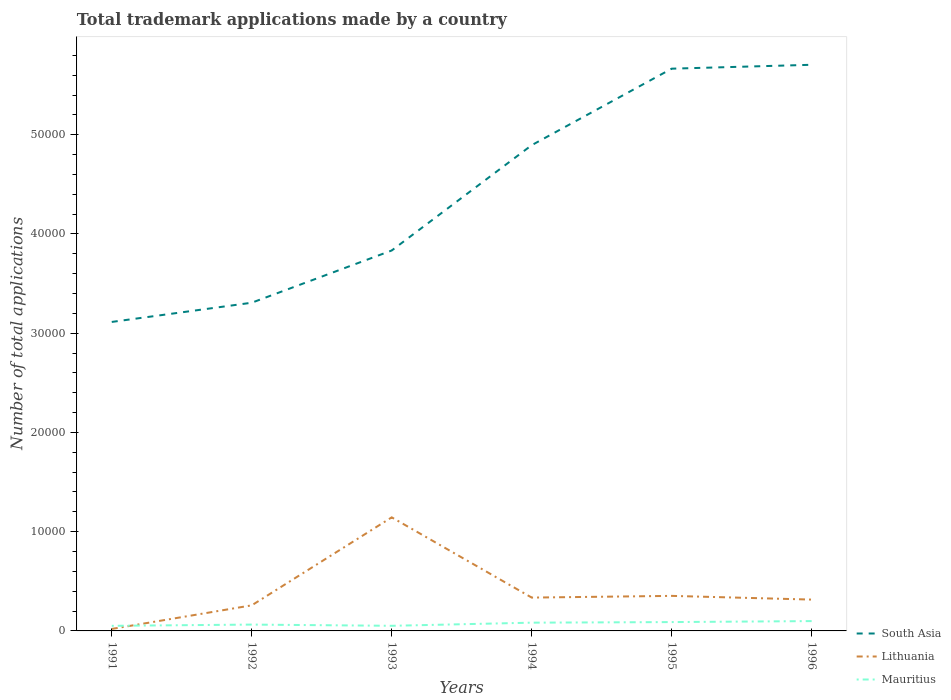How many different coloured lines are there?
Provide a succinct answer. 3. Does the line corresponding to Lithuania intersect with the line corresponding to South Asia?
Give a very brief answer. No. Across all years, what is the maximum number of applications made by in South Asia?
Ensure brevity in your answer.  3.11e+04. In which year was the number of applications made by in Mauritius maximum?
Your answer should be very brief. 1991. What is the total number of applications made by in Lithuania in the graph?
Your answer should be compact. -579. What is the difference between the highest and the second highest number of applications made by in South Asia?
Provide a short and direct response. 2.59e+04. How many years are there in the graph?
Offer a terse response. 6. What is the difference between two consecutive major ticks on the Y-axis?
Your response must be concise. 10000. Are the values on the major ticks of Y-axis written in scientific E-notation?
Your answer should be very brief. No. Does the graph contain grids?
Offer a very short reply. No. How are the legend labels stacked?
Make the answer very short. Vertical. What is the title of the graph?
Offer a very short reply. Total trademark applications made by a country. What is the label or title of the Y-axis?
Offer a terse response. Number of total applications. What is the Number of total applications of South Asia in 1991?
Offer a very short reply. 3.11e+04. What is the Number of total applications of Lithuania in 1991?
Make the answer very short. 200. What is the Number of total applications in Mauritius in 1991?
Keep it short and to the point. 513. What is the Number of total applications in South Asia in 1992?
Provide a short and direct response. 3.31e+04. What is the Number of total applications of Lithuania in 1992?
Offer a very short reply. 2578. What is the Number of total applications of Mauritius in 1992?
Give a very brief answer. 639. What is the Number of total applications in South Asia in 1993?
Provide a succinct answer. 3.83e+04. What is the Number of total applications in Lithuania in 1993?
Your answer should be very brief. 1.14e+04. What is the Number of total applications in Mauritius in 1993?
Keep it short and to the point. 516. What is the Number of total applications of South Asia in 1994?
Provide a short and direct response. 4.90e+04. What is the Number of total applications of Lithuania in 1994?
Keep it short and to the point. 3359. What is the Number of total applications of Mauritius in 1994?
Offer a terse response. 832. What is the Number of total applications in South Asia in 1995?
Your answer should be compact. 5.67e+04. What is the Number of total applications of Lithuania in 1995?
Ensure brevity in your answer.  3531. What is the Number of total applications in Mauritius in 1995?
Keep it short and to the point. 891. What is the Number of total applications of South Asia in 1996?
Offer a terse response. 5.71e+04. What is the Number of total applications of Lithuania in 1996?
Ensure brevity in your answer.  3157. What is the Number of total applications in Mauritius in 1996?
Make the answer very short. 991. Across all years, what is the maximum Number of total applications in South Asia?
Your answer should be very brief. 5.71e+04. Across all years, what is the maximum Number of total applications in Lithuania?
Your answer should be very brief. 1.14e+04. Across all years, what is the maximum Number of total applications in Mauritius?
Your answer should be compact. 991. Across all years, what is the minimum Number of total applications of South Asia?
Provide a short and direct response. 3.11e+04. Across all years, what is the minimum Number of total applications of Mauritius?
Your answer should be compact. 513. What is the total Number of total applications in South Asia in the graph?
Your answer should be very brief. 2.65e+05. What is the total Number of total applications of Lithuania in the graph?
Offer a very short reply. 2.43e+04. What is the total Number of total applications in Mauritius in the graph?
Your answer should be very brief. 4382. What is the difference between the Number of total applications of South Asia in 1991 and that in 1992?
Give a very brief answer. -1937. What is the difference between the Number of total applications of Lithuania in 1991 and that in 1992?
Offer a very short reply. -2378. What is the difference between the Number of total applications of Mauritius in 1991 and that in 1992?
Provide a short and direct response. -126. What is the difference between the Number of total applications of South Asia in 1991 and that in 1993?
Your response must be concise. -7200. What is the difference between the Number of total applications in Lithuania in 1991 and that in 1993?
Keep it short and to the point. -1.12e+04. What is the difference between the Number of total applications in Mauritius in 1991 and that in 1993?
Give a very brief answer. -3. What is the difference between the Number of total applications in South Asia in 1991 and that in 1994?
Ensure brevity in your answer.  -1.78e+04. What is the difference between the Number of total applications in Lithuania in 1991 and that in 1994?
Make the answer very short. -3159. What is the difference between the Number of total applications in Mauritius in 1991 and that in 1994?
Ensure brevity in your answer.  -319. What is the difference between the Number of total applications of South Asia in 1991 and that in 1995?
Keep it short and to the point. -2.55e+04. What is the difference between the Number of total applications of Lithuania in 1991 and that in 1995?
Keep it short and to the point. -3331. What is the difference between the Number of total applications of Mauritius in 1991 and that in 1995?
Offer a very short reply. -378. What is the difference between the Number of total applications of South Asia in 1991 and that in 1996?
Offer a terse response. -2.59e+04. What is the difference between the Number of total applications in Lithuania in 1991 and that in 1996?
Offer a terse response. -2957. What is the difference between the Number of total applications in Mauritius in 1991 and that in 1996?
Make the answer very short. -478. What is the difference between the Number of total applications of South Asia in 1992 and that in 1993?
Make the answer very short. -5263. What is the difference between the Number of total applications in Lithuania in 1992 and that in 1993?
Offer a terse response. -8867. What is the difference between the Number of total applications in Mauritius in 1992 and that in 1993?
Your response must be concise. 123. What is the difference between the Number of total applications in South Asia in 1992 and that in 1994?
Offer a very short reply. -1.59e+04. What is the difference between the Number of total applications in Lithuania in 1992 and that in 1994?
Your answer should be very brief. -781. What is the difference between the Number of total applications of Mauritius in 1992 and that in 1994?
Give a very brief answer. -193. What is the difference between the Number of total applications of South Asia in 1992 and that in 1995?
Your response must be concise. -2.36e+04. What is the difference between the Number of total applications of Lithuania in 1992 and that in 1995?
Offer a very short reply. -953. What is the difference between the Number of total applications in Mauritius in 1992 and that in 1995?
Your answer should be very brief. -252. What is the difference between the Number of total applications of South Asia in 1992 and that in 1996?
Provide a short and direct response. -2.40e+04. What is the difference between the Number of total applications of Lithuania in 1992 and that in 1996?
Give a very brief answer. -579. What is the difference between the Number of total applications of Mauritius in 1992 and that in 1996?
Keep it short and to the point. -352. What is the difference between the Number of total applications of South Asia in 1993 and that in 1994?
Your answer should be very brief. -1.06e+04. What is the difference between the Number of total applications of Lithuania in 1993 and that in 1994?
Your response must be concise. 8086. What is the difference between the Number of total applications in Mauritius in 1993 and that in 1994?
Your response must be concise. -316. What is the difference between the Number of total applications of South Asia in 1993 and that in 1995?
Provide a succinct answer. -1.83e+04. What is the difference between the Number of total applications of Lithuania in 1993 and that in 1995?
Make the answer very short. 7914. What is the difference between the Number of total applications in Mauritius in 1993 and that in 1995?
Your answer should be very brief. -375. What is the difference between the Number of total applications in South Asia in 1993 and that in 1996?
Offer a terse response. -1.87e+04. What is the difference between the Number of total applications of Lithuania in 1993 and that in 1996?
Give a very brief answer. 8288. What is the difference between the Number of total applications in Mauritius in 1993 and that in 1996?
Keep it short and to the point. -475. What is the difference between the Number of total applications in South Asia in 1994 and that in 1995?
Give a very brief answer. -7709. What is the difference between the Number of total applications in Lithuania in 1994 and that in 1995?
Make the answer very short. -172. What is the difference between the Number of total applications of Mauritius in 1994 and that in 1995?
Your response must be concise. -59. What is the difference between the Number of total applications of South Asia in 1994 and that in 1996?
Ensure brevity in your answer.  -8101. What is the difference between the Number of total applications of Lithuania in 1994 and that in 1996?
Provide a succinct answer. 202. What is the difference between the Number of total applications in Mauritius in 1994 and that in 1996?
Provide a succinct answer. -159. What is the difference between the Number of total applications of South Asia in 1995 and that in 1996?
Offer a terse response. -392. What is the difference between the Number of total applications of Lithuania in 1995 and that in 1996?
Keep it short and to the point. 374. What is the difference between the Number of total applications in Mauritius in 1995 and that in 1996?
Your answer should be compact. -100. What is the difference between the Number of total applications in South Asia in 1991 and the Number of total applications in Lithuania in 1992?
Ensure brevity in your answer.  2.86e+04. What is the difference between the Number of total applications of South Asia in 1991 and the Number of total applications of Mauritius in 1992?
Provide a succinct answer. 3.05e+04. What is the difference between the Number of total applications of Lithuania in 1991 and the Number of total applications of Mauritius in 1992?
Ensure brevity in your answer.  -439. What is the difference between the Number of total applications of South Asia in 1991 and the Number of total applications of Lithuania in 1993?
Give a very brief answer. 1.97e+04. What is the difference between the Number of total applications of South Asia in 1991 and the Number of total applications of Mauritius in 1993?
Give a very brief answer. 3.06e+04. What is the difference between the Number of total applications in Lithuania in 1991 and the Number of total applications in Mauritius in 1993?
Provide a short and direct response. -316. What is the difference between the Number of total applications of South Asia in 1991 and the Number of total applications of Lithuania in 1994?
Keep it short and to the point. 2.78e+04. What is the difference between the Number of total applications in South Asia in 1991 and the Number of total applications in Mauritius in 1994?
Give a very brief answer. 3.03e+04. What is the difference between the Number of total applications of Lithuania in 1991 and the Number of total applications of Mauritius in 1994?
Give a very brief answer. -632. What is the difference between the Number of total applications in South Asia in 1991 and the Number of total applications in Lithuania in 1995?
Your response must be concise. 2.76e+04. What is the difference between the Number of total applications of South Asia in 1991 and the Number of total applications of Mauritius in 1995?
Your answer should be very brief. 3.02e+04. What is the difference between the Number of total applications in Lithuania in 1991 and the Number of total applications in Mauritius in 1995?
Provide a succinct answer. -691. What is the difference between the Number of total applications of South Asia in 1991 and the Number of total applications of Lithuania in 1996?
Give a very brief answer. 2.80e+04. What is the difference between the Number of total applications of South Asia in 1991 and the Number of total applications of Mauritius in 1996?
Provide a succinct answer. 3.01e+04. What is the difference between the Number of total applications in Lithuania in 1991 and the Number of total applications in Mauritius in 1996?
Keep it short and to the point. -791. What is the difference between the Number of total applications of South Asia in 1992 and the Number of total applications of Lithuania in 1993?
Ensure brevity in your answer.  2.16e+04. What is the difference between the Number of total applications in South Asia in 1992 and the Number of total applications in Mauritius in 1993?
Give a very brief answer. 3.26e+04. What is the difference between the Number of total applications in Lithuania in 1992 and the Number of total applications in Mauritius in 1993?
Your response must be concise. 2062. What is the difference between the Number of total applications in South Asia in 1992 and the Number of total applications in Lithuania in 1994?
Offer a very short reply. 2.97e+04. What is the difference between the Number of total applications in South Asia in 1992 and the Number of total applications in Mauritius in 1994?
Keep it short and to the point. 3.22e+04. What is the difference between the Number of total applications in Lithuania in 1992 and the Number of total applications in Mauritius in 1994?
Offer a very short reply. 1746. What is the difference between the Number of total applications in South Asia in 1992 and the Number of total applications in Lithuania in 1995?
Provide a succinct answer. 2.95e+04. What is the difference between the Number of total applications in South Asia in 1992 and the Number of total applications in Mauritius in 1995?
Your answer should be compact. 3.22e+04. What is the difference between the Number of total applications of Lithuania in 1992 and the Number of total applications of Mauritius in 1995?
Give a very brief answer. 1687. What is the difference between the Number of total applications of South Asia in 1992 and the Number of total applications of Lithuania in 1996?
Keep it short and to the point. 2.99e+04. What is the difference between the Number of total applications of South Asia in 1992 and the Number of total applications of Mauritius in 1996?
Make the answer very short. 3.21e+04. What is the difference between the Number of total applications of Lithuania in 1992 and the Number of total applications of Mauritius in 1996?
Your answer should be very brief. 1587. What is the difference between the Number of total applications of South Asia in 1993 and the Number of total applications of Lithuania in 1994?
Provide a short and direct response. 3.50e+04. What is the difference between the Number of total applications in South Asia in 1993 and the Number of total applications in Mauritius in 1994?
Your response must be concise. 3.75e+04. What is the difference between the Number of total applications in Lithuania in 1993 and the Number of total applications in Mauritius in 1994?
Your response must be concise. 1.06e+04. What is the difference between the Number of total applications of South Asia in 1993 and the Number of total applications of Lithuania in 1995?
Give a very brief answer. 3.48e+04. What is the difference between the Number of total applications of South Asia in 1993 and the Number of total applications of Mauritius in 1995?
Your answer should be compact. 3.74e+04. What is the difference between the Number of total applications in Lithuania in 1993 and the Number of total applications in Mauritius in 1995?
Offer a very short reply. 1.06e+04. What is the difference between the Number of total applications of South Asia in 1993 and the Number of total applications of Lithuania in 1996?
Your answer should be compact. 3.52e+04. What is the difference between the Number of total applications in South Asia in 1993 and the Number of total applications in Mauritius in 1996?
Give a very brief answer. 3.73e+04. What is the difference between the Number of total applications in Lithuania in 1993 and the Number of total applications in Mauritius in 1996?
Keep it short and to the point. 1.05e+04. What is the difference between the Number of total applications in South Asia in 1994 and the Number of total applications in Lithuania in 1995?
Give a very brief answer. 4.54e+04. What is the difference between the Number of total applications of South Asia in 1994 and the Number of total applications of Mauritius in 1995?
Give a very brief answer. 4.81e+04. What is the difference between the Number of total applications in Lithuania in 1994 and the Number of total applications in Mauritius in 1995?
Your response must be concise. 2468. What is the difference between the Number of total applications in South Asia in 1994 and the Number of total applications in Lithuania in 1996?
Your answer should be compact. 4.58e+04. What is the difference between the Number of total applications in South Asia in 1994 and the Number of total applications in Mauritius in 1996?
Make the answer very short. 4.80e+04. What is the difference between the Number of total applications of Lithuania in 1994 and the Number of total applications of Mauritius in 1996?
Your answer should be very brief. 2368. What is the difference between the Number of total applications in South Asia in 1995 and the Number of total applications in Lithuania in 1996?
Ensure brevity in your answer.  5.35e+04. What is the difference between the Number of total applications in South Asia in 1995 and the Number of total applications in Mauritius in 1996?
Keep it short and to the point. 5.57e+04. What is the difference between the Number of total applications of Lithuania in 1995 and the Number of total applications of Mauritius in 1996?
Your response must be concise. 2540. What is the average Number of total applications in South Asia per year?
Offer a very short reply. 4.42e+04. What is the average Number of total applications in Lithuania per year?
Your response must be concise. 4045. What is the average Number of total applications in Mauritius per year?
Make the answer very short. 730.33. In the year 1991, what is the difference between the Number of total applications in South Asia and Number of total applications in Lithuania?
Your response must be concise. 3.09e+04. In the year 1991, what is the difference between the Number of total applications of South Asia and Number of total applications of Mauritius?
Ensure brevity in your answer.  3.06e+04. In the year 1991, what is the difference between the Number of total applications in Lithuania and Number of total applications in Mauritius?
Give a very brief answer. -313. In the year 1992, what is the difference between the Number of total applications of South Asia and Number of total applications of Lithuania?
Give a very brief answer. 3.05e+04. In the year 1992, what is the difference between the Number of total applications in South Asia and Number of total applications in Mauritius?
Offer a terse response. 3.24e+04. In the year 1992, what is the difference between the Number of total applications of Lithuania and Number of total applications of Mauritius?
Your answer should be compact. 1939. In the year 1993, what is the difference between the Number of total applications in South Asia and Number of total applications in Lithuania?
Your answer should be very brief. 2.69e+04. In the year 1993, what is the difference between the Number of total applications of South Asia and Number of total applications of Mauritius?
Provide a succinct answer. 3.78e+04. In the year 1993, what is the difference between the Number of total applications in Lithuania and Number of total applications in Mauritius?
Offer a very short reply. 1.09e+04. In the year 1994, what is the difference between the Number of total applications of South Asia and Number of total applications of Lithuania?
Provide a succinct answer. 4.56e+04. In the year 1994, what is the difference between the Number of total applications of South Asia and Number of total applications of Mauritius?
Provide a succinct answer. 4.81e+04. In the year 1994, what is the difference between the Number of total applications in Lithuania and Number of total applications in Mauritius?
Provide a short and direct response. 2527. In the year 1995, what is the difference between the Number of total applications of South Asia and Number of total applications of Lithuania?
Your answer should be compact. 5.31e+04. In the year 1995, what is the difference between the Number of total applications in South Asia and Number of total applications in Mauritius?
Give a very brief answer. 5.58e+04. In the year 1995, what is the difference between the Number of total applications of Lithuania and Number of total applications of Mauritius?
Your response must be concise. 2640. In the year 1996, what is the difference between the Number of total applications of South Asia and Number of total applications of Lithuania?
Your answer should be compact. 5.39e+04. In the year 1996, what is the difference between the Number of total applications in South Asia and Number of total applications in Mauritius?
Make the answer very short. 5.61e+04. In the year 1996, what is the difference between the Number of total applications in Lithuania and Number of total applications in Mauritius?
Make the answer very short. 2166. What is the ratio of the Number of total applications in South Asia in 1991 to that in 1992?
Make the answer very short. 0.94. What is the ratio of the Number of total applications in Lithuania in 1991 to that in 1992?
Offer a terse response. 0.08. What is the ratio of the Number of total applications in Mauritius in 1991 to that in 1992?
Give a very brief answer. 0.8. What is the ratio of the Number of total applications in South Asia in 1991 to that in 1993?
Offer a very short reply. 0.81. What is the ratio of the Number of total applications of Lithuania in 1991 to that in 1993?
Provide a short and direct response. 0.02. What is the ratio of the Number of total applications of Mauritius in 1991 to that in 1993?
Offer a very short reply. 0.99. What is the ratio of the Number of total applications of South Asia in 1991 to that in 1994?
Make the answer very short. 0.64. What is the ratio of the Number of total applications in Lithuania in 1991 to that in 1994?
Give a very brief answer. 0.06. What is the ratio of the Number of total applications in Mauritius in 1991 to that in 1994?
Give a very brief answer. 0.62. What is the ratio of the Number of total applications in South Asia in 1991 to that in 1995?
Give a very brief answer. 0.55. What is the ratio of the Number of total applications in Lithuania in 1991 to that in 1995?
Ensure brevity in your answer.  0.06. What is the ratio of the Number of total applications in Mauritius in 1991 to that in 1995?
Offer a terse response. 0.58. What is the ratio of the Number of total applications in South Asia in 1991 to that in 1996?
Your answer should be compact. 0.55. What is the ratio of the Number of total applications of Lithuania in 1991 to that in 1996?
Your response must be concise. 0.06. What is the ratio of the Number of total applications of Mauritius in 1991 to that in 1996?
Provide a short and direct response. 0.52. What is the ratio of the Number of total applications of South Asia in 1992 to that in 1993?
Provide a succinct answer. 0.86. What is the ratio of the Number of total applications of Lithuania in 1992 to that in 1993?
Give a very brief answer. 0.23. What is the ratio of the Number of total applications of Mauritius in 1992 to that in 1993?
Keep it short and to the point. 1.24. What is the ratio of the Number of total applications of South Asia in 1992 to that in 1994?
Provide a short and direct response. 0.68. What is the ratio of the Number of total applications of Lithuania in 1992 to that in 1994?
Offer a very short reply. 0.77. What is the ratio of the Number of total applications in Mauritius in 1992 to that in 1994?
Make the answer very short. 0.77. What is the ratio of the Number of total applications in South Asia in 1992 to that in 1995?
Your response must be concise. 0.58. What is the ratio of the Number of total applications of Lithuania in 1992 to that in 1995?
Offer a very short reply. 0.73. What is the ratio of the Number of total applications of Mauritius in 1992 to that in 1995?
Your answer should be compact. 0.72. What is the ratio of the Number of total applications of South Asia in 1992 to that in 1996?
Give a very brief answer. 0.58. What is the ratio of the Number of total applications of Lithuania in 1992 to that in 1996?
Your answer should be compact. 0.82. What is the ratio of the Number of total applications of Mauritius in 1992 to that in 1996?
Keep it short and to the point. 0.64. What is the ratio of the Number of total applications in South Asia in 1993 to that in 1994?
Provide a succinct answer. 0.78. What is the ratio of the Number of total applications of Lithuania in 1993 to that in 1994?
Ensure brevity in your answer.  3.41. What is the ratio of the Number of total applications in Mauritius in 1993 to that in 1994?
Provide a succinct answer. 0.62. What is the ratio of the Number of total applications of South Asia in 1993 to that in 1995?
Your answer should be compact. 0.68. What is the ratio of the Number of total applications in Lithuania in 1993 to that in 1995?
Provide a succinct answer. 3.24. What is the ratio of the Number of total applications in Mauritius in 1993 to that in 1995?
Give a very brief answer. 0.58. What is the ratio of the Number of total applications of South Asia in 1993 to that in 1996?
Offer a very short reply. 0.67. What is the ratio of the Number of total applications in Lithuania in 1993 to that in 1996?
Ensure brevity in your answer.  3.63. What is the ratio of the Number of total applications in Mauritius in 1993 to that in 1996?
Your answer should be very brief. 0.52. What is the ratio of the Number of total applications in South Asia in 1994 to that in 1995?
Offer a terse response. 0.86. What is the ratio of the Number of total applications in Lithuania in 1994 to that in 1995?
Keep it short and to the point. 0.95. What is the ratio of the Number of total applications of Mauritius in 1994 to that in 1995?
Your response must be concise. 0.93. What is the ratio of the Number of total applications in South Asia in 1994 to that in 1996?
Give a very brief answer. 0.86. What is the ratio of the Number of total applications of Lithuania in 1994 to that in 1996?
Make the answer very short. 1.06. What is the ratio of the Number of total applications of Mauritius in 1994 to that in 1996?
Your answer should be very brief. 0.84. What is the ratio of the Number of total applications in South Asia in 1995 to that in 1996?
Keep it short and to the point. 0.99. What is the ratio of the Number of total applications in Lithuania in 1995 to that in 1996?
Your response must be concise. 1.12. What is the ratio of the Number of total applications of Mauritius in 1995 to that in 1996?
Give a very brief answer. 0.9. What is the difference between the highest and the second highest Number of total applications of South Asia?
Provide a short and direct response. 392. What is the difference between the highest and the second highest Number of total applications of Lithuania?
Offer a terse response. 7914. What is the difference between the highest and the lowest Number of total applications of South Asia?
Offer a very short reply. 2.59e+04. What is the difference between the highest and the lowest Number of total applications in Lithuania?
Your answer should be very brief. 1.12e+04. What is the difference between the highest and the lowest Number of total applications of Mauritius?
Provide a short and direct response. 478. 